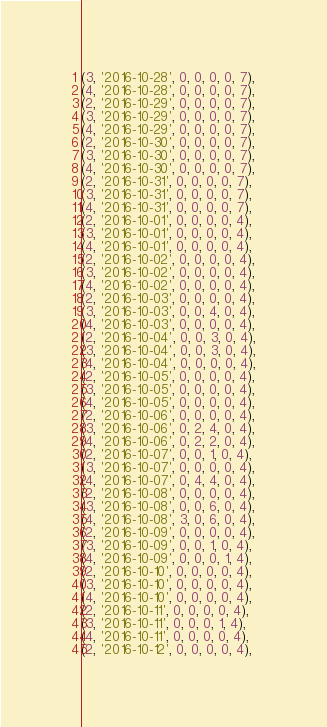<code> <loc_0><loc_0><loc_500><loc_500><_SQL_>(3, '2016-10-28', 0, 0, 0, 0, 7),
(4, '2016-10-28', 0, 0, 0, 0, 7),
(2, '2016-10-29', 0, 0, 0, 0, 7),
(3, '2016-10-29', 0, 0, 0, 0, 7),
(4, '2016-10-29', 0, 0, 0, 0, 7),
(2, '2016-10-30', 0, 0, 0, 0, 7),
(3, '2016-10-30', 0, 0, 0, 0, 7),
(4, '2016-10-30', 0, 0, 0, 0, 7),
(2, '2016-10-31', 0, 0, 0, 0, 7),
(3, '2016-10-31', 0, 0, 0, 0, 7),
(4, '2016-10-31', 0, 0, 0, 0, 7),
(2, '2016-10-01', 0, 0, 0, 0, 4),
(3, '2016-10-01', 0, 0, 0, 0, 4),
(4, '2016-10-01', 0, 0, 0, 0, 4),
(2, '2016-10-02', 0, 0, 0, 0, 4),
(3, '2016-10-02', 0, 0, 0, 0, 4),
(4, '2016-10-02', 0, 0, 0, 0, 4),
(2, '2016-10-03', 0, 0, 0, 0, 4),
(3, '2016-10-03', 0, 0, 4, 0, 4),
(4, '2016-10-03', 0, 0, 0, 0, 4),
(2, '2016-10-04', 0, 0, 3, 0, 4),
(3, '2016-10-04', 0, 0, 3, 0, 4),
(4, '2016-10-04', 0, 0, 0, 0, 4),
(2, '2016-10-05', 0, 0, 0, 0, 4),
(3, '2016-10-05', 0, 0, 0, 0, 4),
(4, '2016-10-05', 0, 0, 0, 0, 4),
(2, '2016-10-06', 0, 0, 0, 0, 4),
(3, '2016-10-06', 0, 2, 4, 0, 4),
(4, '2016-10-06', 0, 2, 2, 0, 4),
(2, '2016-10-07', 0, 0, 1, 0, 4),
(3, '2016-10-07', 0, 0, 0, 0, 4),
(4, '2016-10-07', 0, 4, 4, 0, 4),
(2, '2016-10-08', 0, 0, 0, 0, 4),
(3, '2016-10-08', 0, 0, 6, 0, 4),
(4, '2016-10-08', 3, 0, 6, 0, 4),
(2, '2016-10-09', 0, 0, 0, 0, 4),
(3, '2016-10-09', 0, 0, 1, 0, 4),
(4, '2016-10-09', 0, 0, 0, 1, 4),
(2, '2016-10-10', 0, 0, 0, 0, 4),
(3, '2016-10-10', 0, 0, 0, 0, 4),
(4, '2016-10-10', 0, 0, 0, 0, 4),
(2, '2016-10-11', 0, 0, 0, 0, 4),
(3, '2016-10-11', 0, 0, 0, 1, 4),
(4, '2016-10-11', 0, 0, 0, 0, 4),
(2, '2016-10-12', 0, 0, 0, 0, 4),</code> 